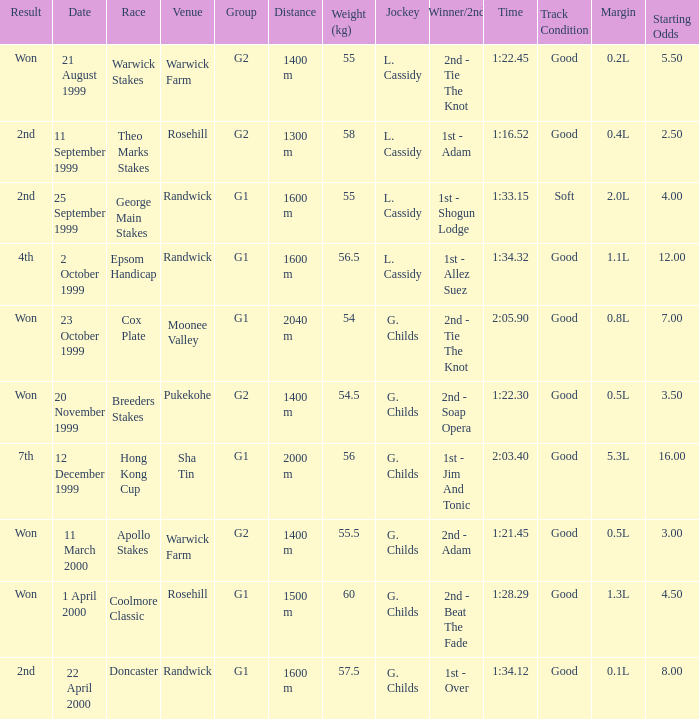List the weight for 56 kilograms. 2000 m. 